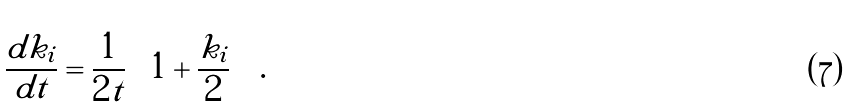<formula> <loc_0><loc_0><loc_500><loc_500>\frac { d k _ { i } } { d t } = \frac { 1 } { 2 t } \left ( 1 + \frac { k _ { i } } { 2 } \right ) \, .</formula> 